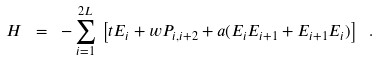<formula> <loc_0><loc_0><loc_500><loc_500>H \ = \ - \sum _ { i = 1 } ^ { 2 L } \, \left [ t E _ { i } + w P _ { i , i + 2 } + a ( E _ { i } E _ { i + 1 } + E _ { i + 1 } E _ { i } ) \right ] \ .</formula> 